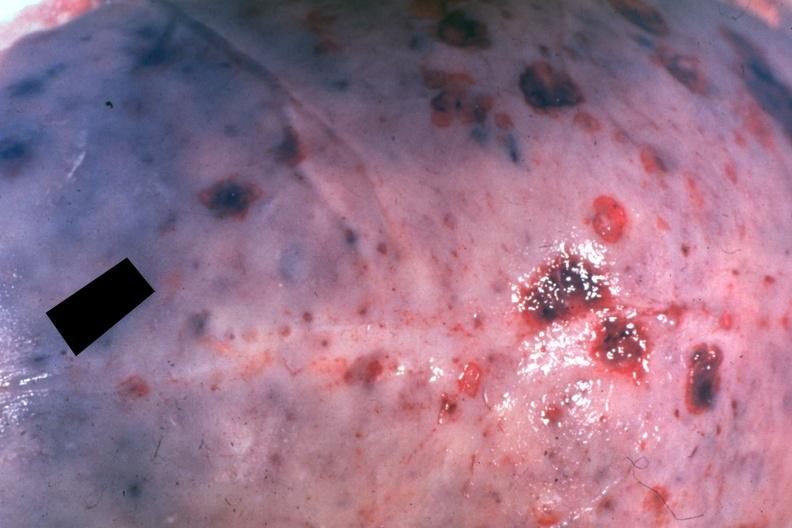what is present?
Answer the question using a single word or phrase. Bone 